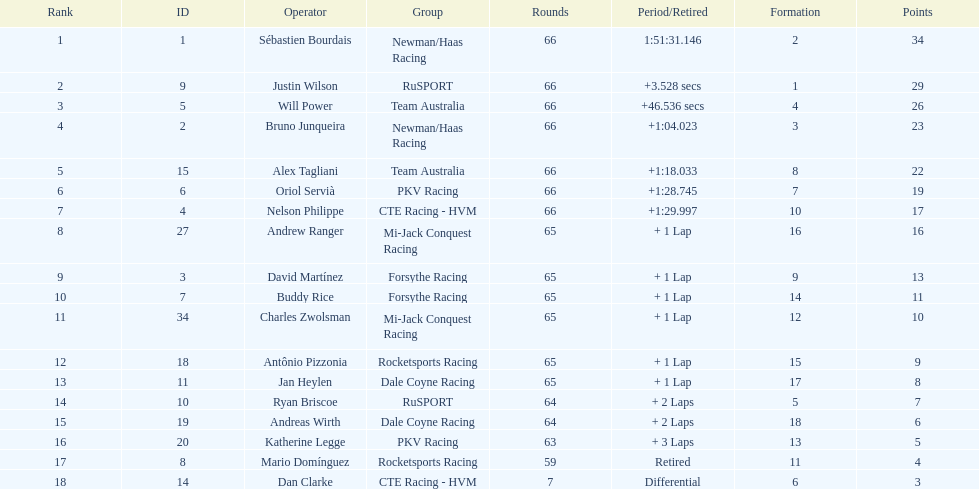Who accumulated the highest points during the 2006 gran premio telmex? Sébastien Bourdais. 